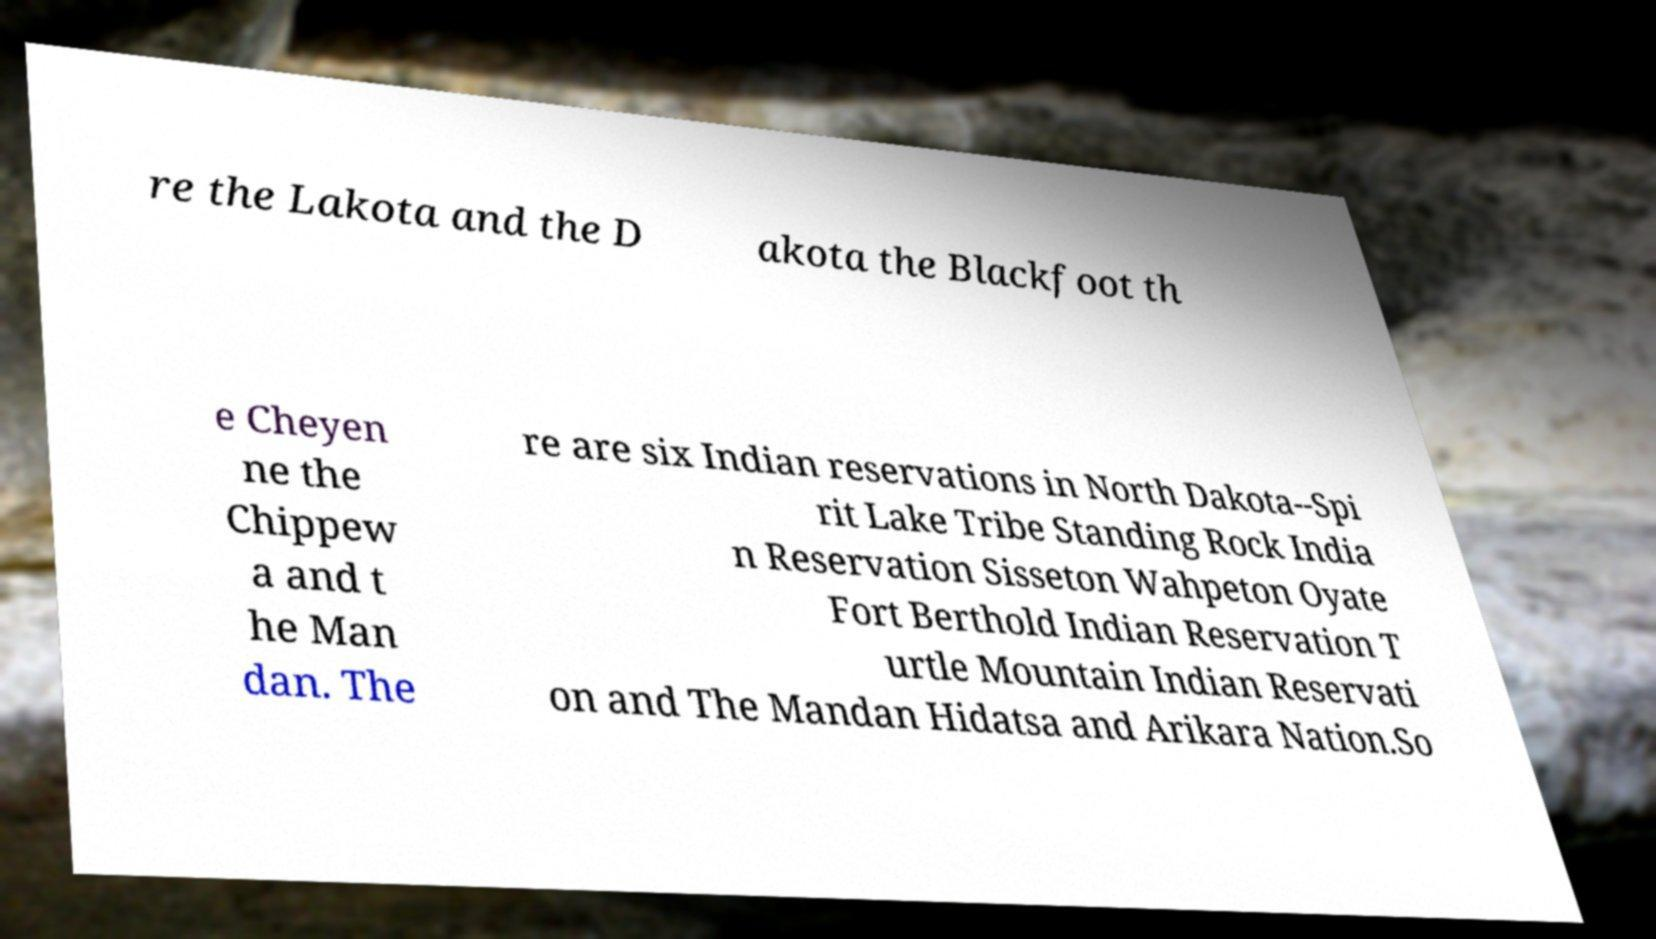There's text embedded in this image that I need extracted. Can you transcribe it verbatim? re the Lakota and the D akota the Blackfoot th e Cheyen ne the Chippew a and t he Man dan. The re are six Indian reservations in North Dakota--Spi rit Lake Tribe Standing Rock India n Reservation Sisseton Wahpeton Oyate Fort Berthold Indian Reservation T urtle Mountain Indian Reservati on and The Mandan Hidatsa and Arikara Nation.So 